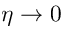<formula> <loc_0><loc_0><loc_500><loc_500>\eta \rightarrow 0</formula> 